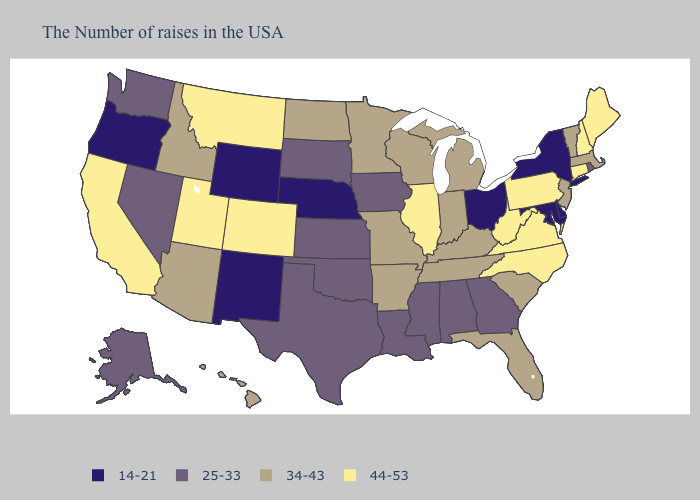What is the highest value in the West ?
Answer briefly. 44-53. Name the states that have a value in the range 25-33?
Quick response, please. Rhode Island, Georgia, Alabama, Mississippi, Louisiana, Iowa, Kansas, Oklahoma, Texas, South Dakota, Nevada, Washington, Alaska. Name the states that have a value in the range 34-43?
Be succinct. Massachusetts, Vermont, New Jersey, South Carolina, Florida, Michigan, Kentucky, Indiana, Tennessee, Wisconsin, Missouri, Arkansas, Minnesota, North Dakota, Arizona, Idaho, Hawaii. Among the states that border Utah , which have the lowest value?
Answer briefly. Wyoming, New Mexico. Name the states that have a value in the range 14-21?
Short answer required. New York, Delaware, Maryland, Ohio, Nebraska, Wyoming, New Mexico, Oregon. Which states have the highest value in the USA?
Answer briefly. Maine, New Hampshire, Connecticut, Pennsylvania, Virginia, North Carolina, West Virginia, Illinois, Colorado, Utah, Montana, California. Name the states that have a value in the range 44-53?
Keep it brief. Maine, New Hampshire, Connecticut, Pennsylvania, Virginia, North Carolina, West Virginia, Illinois, Colorado, Utah, Montana, California. What is the value of Oklahoma?
Give a very brief answer. 25-33. Does Louisiana have a higher value than Oregon?
Quick response, please. Yes. What is the value of Nevada?
Quick response, please. 25-33. Name the states that have a value in the range 14-21?
Be succinct. New York, Delaware, Maryland, Ohio, Nebraska, Wyoming, New Mexico, Oregon. Among the states that border Vermont , does New Hampshire have the lowest value?
Keep it brief. No. Does New Hampshire have the highest value in the Northeast?
Write a very short answer. Yes. Does New Hampshire have the lowest value in the USA?
Short answer required. No. Does Mississippi have the highest value in the South?
Answer briefly. No. 